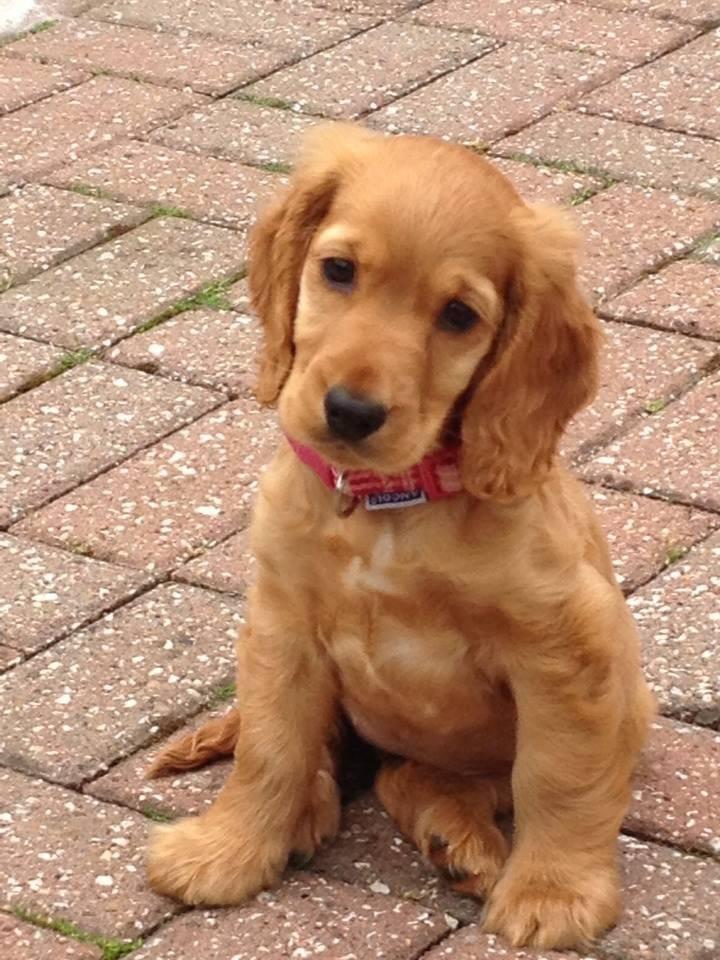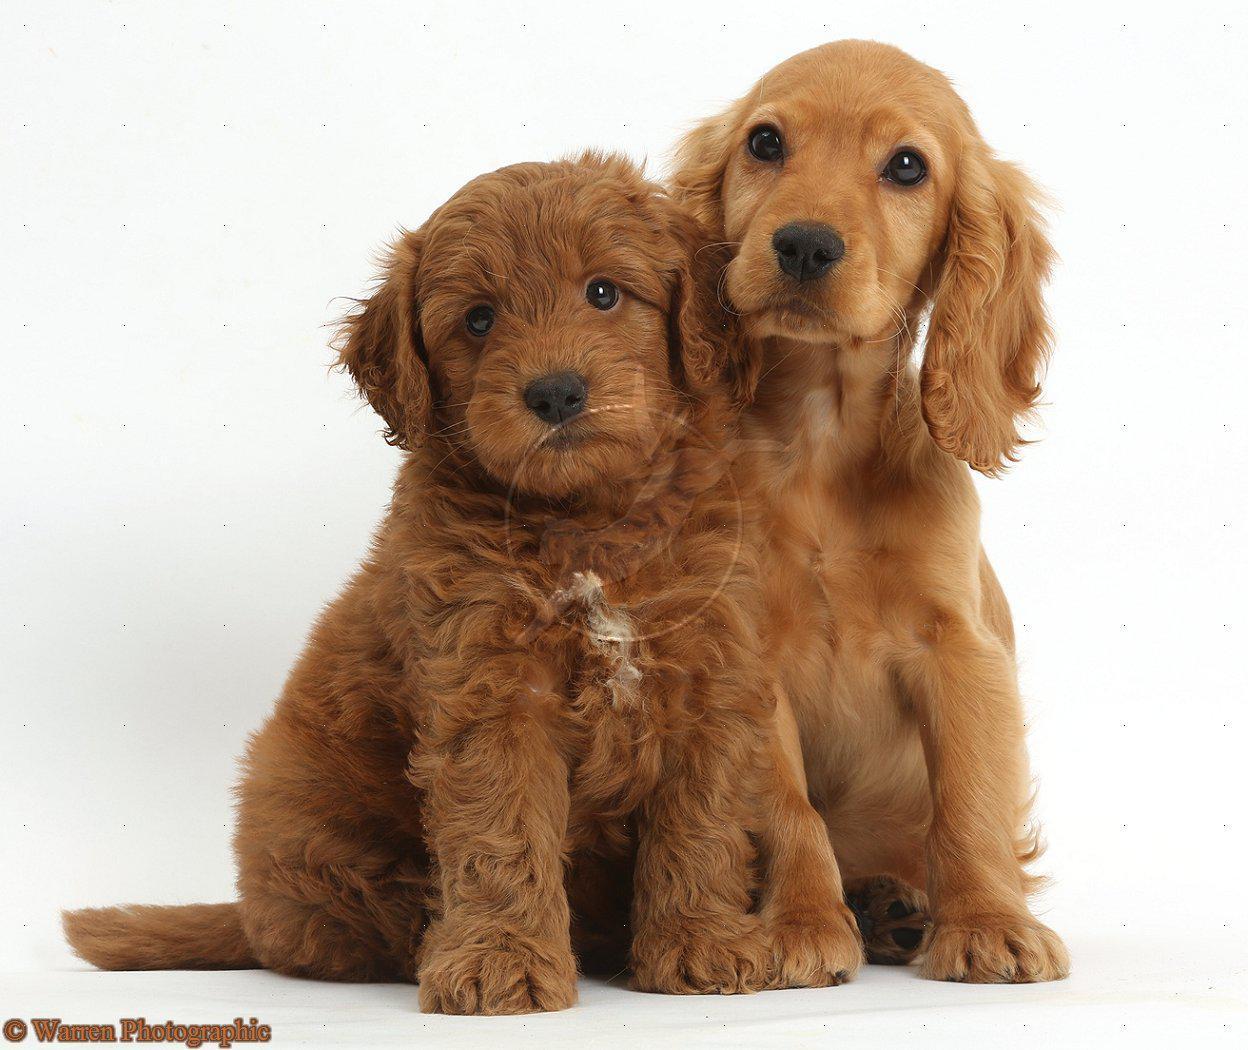The first image is the image on the left, the second image is the image on the right. Evaluate the accuracy of this statement regarding the images: "One image contains one forward-facing orange spaniel with wet fur, posed in front of the ocean.". Is it true? Answer yes or no. No. The first image is the image on the left, the second image is the image on the right. Examine the images to the left and right. Is the description "An image contains exactly two dogs." accurate? Answer yes or no. Yes. 